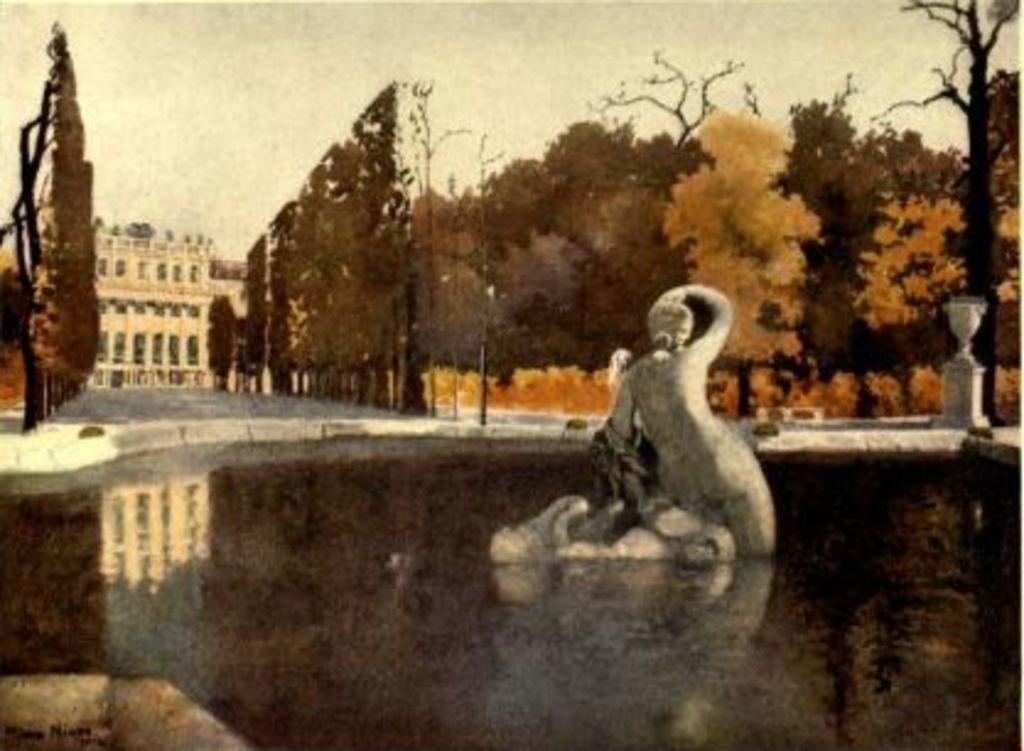What is the main feature in the image? There is a pond in the image. What is located in the middle of the pond? There is a sculpture in the middle of the pond. What can be seen in the background of the image? There are trees, buildings, and the sky visible in the background of the image. What type of zipper can be seen on the birthday building in the image? There is no zipper or birthday building present in the image. 